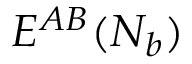Convert formula to latex. <formula><loc_0><loc_0><loc_500><loc_500>E ^ { A B } ( N _ { b } )</formula> 